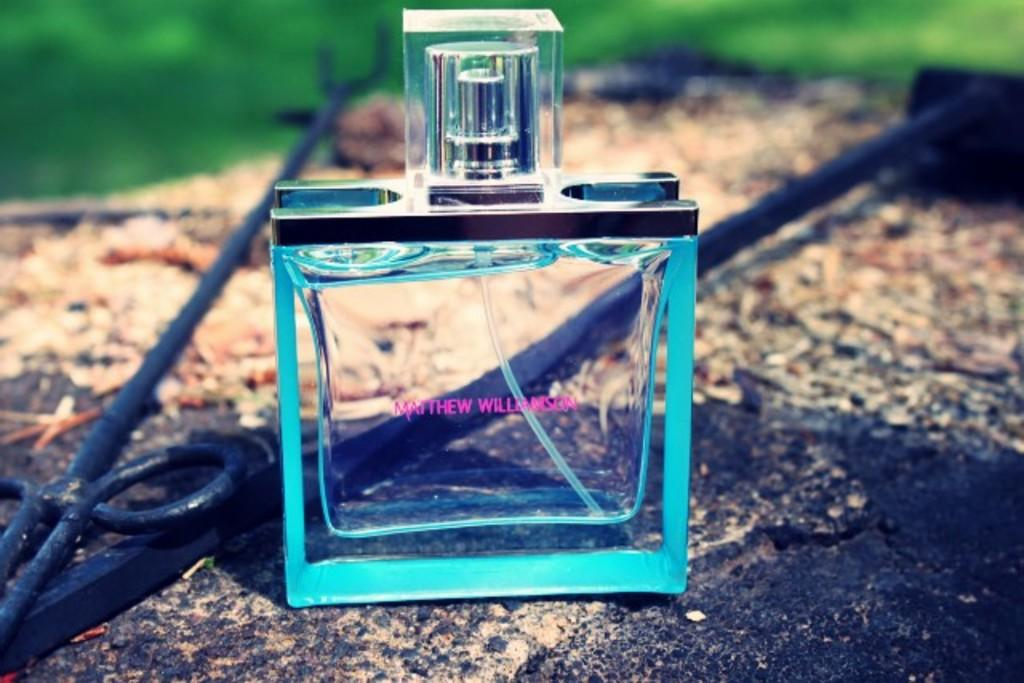<image>
Offer a succinct explanation of the picture presented. A blue bottle of cologne made by Matthew Williamson sitting on a rock. 